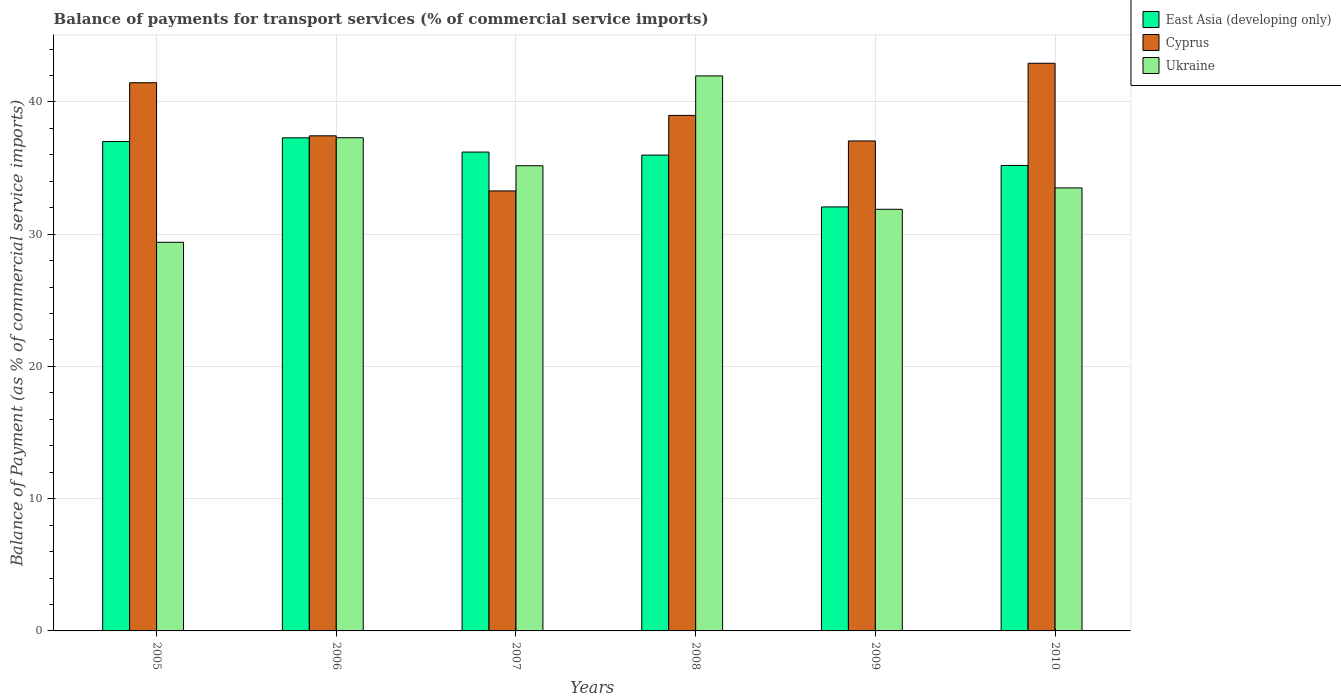Are the number of bars per tick equal to the number of legend labels?
Give a very brief answer. Yes. How many bars are there on the 3rd tick from the right?
Offer a very short reply. 3. In how many cases, is the number of bars for a given year not equal to the number of legend labels?
Provide a short and direct response. 0. What is the balance of payments for transport services in Cyprus in 2007?
Your response must be concise. 33.27. Across all years, what is the maximum balance of payments for transport services in Ukraine?
Ensure brevity in your answer.  41.97. Across all years, what is the minimum balance of payments for transport services in Ukraine?
Ensure brevity in your answer.  29.39. In which year was the balance of payments for transport services in Ukraine minimum?
Keep it short and to the point. 2005. What is the total balance of payments for transport services in Cyprus in the graph?
Provide a succinct answer. 231.12. What is the difference between the balance of payments for transport services in Cyprus in 2005 and that in 2006?
Your answer should be compact. 4.01. What is the difference between the balance of payments for transport services in East Asia (developing only) in 2010 and the balance of payments for transport services in Ukraine in 2005?
Offer a terse response. 5.81. What is the average balance of payments for transport services in Cyprus per year?
Offer a very short reply. 38.52. In the year 2010, what is the difference between the balance of payments for transport services in East Asia (developing only) and balance of payments for transport services in Ukraine?
Provide a succinct answer. 1.7. What is the ratio of the balance of payments for transport services in Ukraine in 2006 to that in 2009?
Provide a succinct answer. 1.17. What is the difference between the highest and the second highest balance of payments for transport services in East Asia (developing only)?
Your answer should be very brief. 0.28. What is the difference between the highest and the lowest balance of payments for transport services in Ukraine?
Your answer should be compact. 12.58. Is the sum of the balance of payments for transport services in East Asia (developing only) in 2008 and 2010 greater than the maximum balance of payments for transport services in Cyprus across all years?
Ensure brevity in your answer.  Yes. What does the 2nd bar from the left in 2006 represents?
Keep it short and to the point. Cyprus. What does the 1st bar from the right in 2005 represents?
Your answer should be compact. Ukraine. How many bars are there?
Offer a terse response. 18. How many years are there in the graph?
Your answer should be compact. 6. What is the difference between two consecutive major ticks on the Y-axis?
Ensure brevity in your answer.  10. How many legend labels are there?
Your response must be concise. 3. What is the title of the graph?
Offer a terse response. Balance of payments for transport services (% of commercial service imports). What is the label or title of the X-axis?
Your response must be concise. Years. What is the label or title of the Y-axis?
Your answer should be compact. Balance of Payment (as % of commercial service imports). What is the Balance of Payment (as % of commercial service imports) in East Asia (developing only) in 2005?
Your answer should be very brief. 37.01. What is the Balance of Payment (as % of commercial service imports) of Cyprus in 2005?
Offer a terse response. 41.45. What is the Balance of Payment (as % of commercial service imports) in Ukraine in 2005?
Your response must be concise. 29.39. What is the Balance of Payment (as % of commercial service imports) in East Asia (developing only) in 2006?
Offer a very short reply. 37.29. What is the Balance of Payment (as % of commercial service imports) of Cyprus in 2006?
Offer a very short reply. 37.44. What is the Balance of Payment (as % of commercial service imports) in Ukraine in 2006?
Give a very brief answer. 37.3. What is the Balance of Payment (as % of commercial service imports) in East Asia (developing only) in 2007?
Your response must be concise. 36.21. What is the Balance of Payment (as % of commercial service imports) of Cyprus in 2007?
Your response must be concise. 33.27. What is the Balance of Payment (as % of commercial service imports) of Ukraine in 2007?
Offer a very short reply. 35.18. What is the Balance of Payment (as % of commercial service imports) of East Asia (developing only) in 2008?
Make the answer very short. 35.98. What is the Balance of Payment (as % of commercial service imports) in Cyprus in 2008?
Provide a succinct answer. 38.98. What is the Balance of Payment (as % of commercial service imports) in Ukraine in 2008?
Offer a terse response. 41.97. What is the Balance of Payment (as % of commercial service imports) of East Asia (developing only) in 2009?
Provide a succinct answer. 32.06. What is the Balance of Payment (as % of commercial service imports) in Cyprus in 2009?
Offer a terse response. 37.05. What is the Balance of Payment (as % of commercial service imports) in Ukraine in 2009?
Your answer should be compact. 31.88. What is the Balance of Payment (as % of commercial service imports) of East Asia (developing only) in 2010?
Provide a short and direct response. 35.2. What is the Balance of Payment (as % of commercial service imports) in Cyprus in 2010?
Ensure brevity in your answer.  42.93. What is the Balance of Payment (as % of commercial service imports) in Ukraine in 2010?
Provide a short and direct response. 33.5. Across all years, what is the maximum Balance of Payment (as % of commercial service imports) of East Asia (developing only)?
Your answer should be compact. 37.29. Across all years, what is the maximum Balance of Payment (as % of commercial service imports) of Cyprus?
Give a very brief answer. 42.93. Across all years, what is the maximum Balance of Payment (as % of commercial service imports) in Ukraine?
Offer a terse response. 41.97. Across all years, what is the minimum Balance of Payment (as % of commercial service imports) of East Asia (developing only)?
Provide a succinct answer. 32.06. Across all years, what is the minimum Balance of Payment (as % of commercial service imports) in Cyprus?
Provide a short and direct response. 33.27. Across all years, what is the minimum Balance of Payment (as % of commercial service imports) in Ukraine?
Ensure brevity in your answer.  29.39. What is the total Balance of Payment (as % of commercial service imports) in East Asia (developing only) in the graph?
Provide a short and direct response. 213.74. What is the total Balance of Payment (as % of commercial service imports) in Cyprus in the graph?
Your response must be concise. 231.12. What is the total Balance of Payment (as % of commercial service imports) of Ukraine in the graph?
Provide a short and direct response. 209.21. What is the difference between the Balance of Payment (as % of commercial service imports) in East Asia (developing only) in 2005 and that in 2006?
Your answer should be compact. -0.28. What is the difference between the Balance of Payment (as % of commercial service imports) of Cyprus in 2005 and that in 2006?
Provide a succinct answer. 4.01. What is the difference between the Balance of Payment (as % of commercial service imports) of Ukraine in 2005 and that in 2006?
Make the answer very short. -7.91. What is the difference between the Balance of Payment (as % of commercial service imports) in East Asia (developing only) in 2005 and that in 2007?
Offer a very short reply. 0.8. What is the difference between the Balance of Payment (as % of commercial service imports) of Cyprus in 2005 and that in 2007?
Your answer should be compact. 8.18. What is the difference between the Balance of Payment (as % of commercial service imports) in Ukraine in 2005 and that in 2007?
Provide a short and direct response. -5.79. What is the difference between the Balance of Payment (as % of commercial service imports) of East Asia (developing only) in 2005 and that in 2008?
Your answer should be compact. 1.03. What is the difference between the Balance of Payment (as % of commercial service imports) in Cyprus in 2005 and that in 2008?
Keep it short and to the point. 2.47. What is the difference between the Balance of Payment (as % of commercial service imports) in Ukraine in 2005 and that in 2008?
Make the answer very short. -12.58. What is the difference between the Balance of Payment (as % of commercial service imports) of East Asia (developing only) in 2005 and that in 2009?
Your response must be concise. 4.94. What is the difference between the Balance of Payment (as % of commercial service imports) of Cyprus in 2005 and that in 2009?
Keep it short and to the point. 4.4. What is the difference between the Balance of Payment (as % of commercial service imports) in Ukraine in 2005 and that in 2009?
Offer a terse response. -2.49. What is the difference between the Balance of Payment (as % of commercial service imports) of East Asia (developing only) in 2005 and that in 2010?
Keep it short and to the point. 1.81. What is the difference between the Balance of Payment (as % of commercial service imports) in Cyprus in 2005 and that in 2010?
Ensure brevity in your answer.  -1.47. What is the difference between the Balance of Payment (as % of commercial service imports) in Ukraine in 2005 and that in 2010?
Offer a terse response. -4.11. What is the difference between the Balance of Payment (as % of commercial service imports) of East Asia (developing only) in 2006 and that in 2007?
Your answer should be very brief. 1.08. What is the difference between the Balance of Payment (as % of commercial service imports) in Cyprus in 2006 and that in 2007?
Ensure brevity in your answer.  4.17. What is the difference between the Balance of Payment (as % of commercial service imports) of Ukraine in 2006 and that in 2007?
Ensure brevity in your answer.  2.12. What is the difference between the Balance of Payment (as % of commercial service imports) of East Asia (developing only) in 2006 and that in 2008?
Make the answer very short. 1.31. What is the difference between the Balance of Payment (as % of commercial service imports) of Cyprus in 2006 and that in 2008?
Ensure brevity in your answer.  -1.54. What is the difference between the Balance of Payment (as % of commercial service imports) in Ukraine in 2006 and that in 2008?
Keep it short and to the point. -4.67. What is the difference between the Balance of Payment (as % of commercial service imports) of East Asia (developing only) in 2006 and that in 2009?
Your response must be concise. 5.22. What is the difference between the Balance of Payment (as % of commercial service imports) of Cyprus in 2006 and that in 2009?
Provide a short and direct response. 0.39. What is the difference between the Balance of Payment (as % of commercial service imports) of Ukraine in 2006 and that in 2009?
Your answer should be very brief. 5.41. What is the difference between the Balance of Payment (as % of commercial service imports) of East Asia (developing only) in 2006 and that in 2010?
Keep it short and to the point. 2.09. What is the difference between the Balance of Payment (as % of commercial service imports) in Cyprus in 2006 and that in 2010?
Your answer should be compact. -5.49. What is the difference between the Balance of Payment (as % of commercial service imports) in Ukraine in 2006 and that in 2010?
Offer a very short reply. 3.8. What is the difference between the Balance of Payment (as % of commercial service imports) in East Asia (developing only) in 2007 and that in 2008?
Your answer should be compact. 0.23. What is the difference between the Balance of Payment (as % of commercial service imports) in Cyprus in 2007 and that in 2008?
Offer a terse response. -5.71. What is the difference between the Balance of Payment (as % of commercial service imports) of Ukraine in 2007 and that in 2008?
Keep it short and to the point. -6.79. What is the difference between the Balance of Payment (as % of commercial service imports) of East Asia (developing only) in 2007 and that in 2009?
Offer a very short reply. 4.15. What is the difference between the Balance of Payment (as % of commercial service imports) of Cyprus in 2007 and that in 2009?
Provide a short and direct response. -3.78. What is the difference between the Balance of Payment (as % of commercial service imports) in Ukraine in 2007 and that in 2009?
Offer a very short reply. 3.29. What is the difference between the Balance of Payment (as % of commercial service imports) in East Asia (developing only) in 2007 and that in 2010?
Your response must be concise. 1.01. What is the difference between the Balance of Payment (as % of commercial service imports) in Cyprus in 2007 and that in 2010?
Your response must be concise. -9.65. What is the difference between the Balance of Payment (as % of commercial service imports) of Ukraine in 2007 and that in 2010?
Your response must be concise. 1.68. What is the difference between the Balance of Payment (as % of commercial service imports) in East Asia (developing only) in 2008 and that in 2009?
Offer a very short reply. 3.92. What is the difference between the Balance of Payment (as % of commercial service imports) in Cyprus in 2008 and that in 2009?
Your answer should be compact. 1.93. What is the difference between the Balance of Payment (as % of commercial service imports) in Ukraine in 2008 and that in 2009?
Provide a short and direct response. 10.09. What is the difference between the Balance of Payment (as % of commercial service imports) of East Asia (developing only) in 2008 and that in 2010?
Make the answer very short. 0.78. What is the difference between the Balance of Payment (as % of commercial service imports) in Cyprus in 2008 and that in 2010?
Your answer should be compact. -3.94. What is the difference between the Balance of Payment (as % of commercial service imports) of Ukraine in 2008 and that in 2010?
Your response must be concise. 8.47. What is the difference between the Balance of Payment (as % of commercial service imports) of East Asia (developing only) in 2009 and that in 2010?
Your answer should be very brief. -3.13. What is the difference between the Balance of Payment (as % of commercial service imports) of Cyprus in 2009 and that in 2010?
Provide a short and direct response. -5.87. What is the difference between the Balance of Payment (as % of commercial service imports) in Ukraine in 2009 and that in 2010?
Ensure brevity in your answer.  -1.61. What is the difference between the Balance of Payment (as % of commercial service imports) of East Asia (developing only) in 2005 and the Balance of Payment (as % of commercial service imports) of Cyprus in 2006?
Make the answer very short. -0.43. What is the difference between the Balance of Payment (as % of commercial service imports) of East Asia (developing only) in 2005 and the Balance of Payment (as % of commercial service imports) of Ukraine in 2006?
Give a very brief answer. -0.29. What is the difference between the Balance of Payment (as % of commercial service imports) in Cyprus in 2005 and the Balance of Payment (as % of commercial service imports) in Ukraine in 2006?
Offer a terse response. 4.16. What is the difference between the Balance of Payment (as % of commercial service imports) of East Asia (developing only) in 2005 and the Balance of Payment (as % of commercial service imports) of Cyprus in 2007?
Your answer should be compact. 3.73. What is the difference between the Balance of Payment (as % of commercial service imports) in East Asia (developing only) in 2005 and the Balance of Payment (as % of commercial service imports) in Ukraine in 2007?
Make the answer very short. 1.83. What is the difference between the Balance of Payment (as % of commercial service imports) in Cyprus in 2005 and the Balance of Payment (as % of commercial service imports) in Ukraine in 2007?
Your answer should be compact. 6.28. What is the difference between the Balance of Payment (as % of commercial service imports) of East Asia (developing only) in 2005 and the Balance of Payment (as % of commercial service imports) of Cyprus in 2008?
Provide a succinct answer. -1.98. What is the difference between the Balance of Payment (as % of commercial service imports) of East Asia (developing only) in 2005 and the Balance of Payment (as % of commercial service imports) of Ukraine in 2008?
Provide a succinct answer. -4.96. What is the difference between the Balance of Payment (as % of commercial service imports) of Cyprus in 2005 and the Balance of Payment (as % of commercial service imports) of Ukraine in 2008?
Offer a very short reply. -0.52. What is the difference between the Balance of Payment (as % of commercial service imports) in East Asia (developing only) in 2005 and the Balance of Payment (as % of commercial service imports) in Cyprus in 2009?
Give a very brief answer. -0.04. What is the difference between the Balance of Payment (as % of commercial service imports) of East Asia (developing only) in 2005 and the Balance of Payment (as % of commercial service imports) of Ukraine in 2009?
Make the answer very short. 5.12. What is the difference between the Balance of Payment (as % of commercial service imports) of Cyprus in 2005 and the Balance of Payment (as % of commercial service imports) of Ukraine in 2009?
Offer a very short reply. 9.57. What is the difference between the Balance of Payment (as % of commercial service imports) of East Asia (developing only) in 2005 and the Balance of Payment (as % of commercial service imports) of Cyprus in 2010?
Your answer should be compact. -5.92. What is the difference between the Balance of Payment (as % of commercial service imports) of East Asia (developing only) in 2005 and the Balance of Payment (as % of commercial service imports) of Ukraine in 2010?
Your answer should be compact. 3.51. What is the difference between the Balance of Payment (as % of commercial service imports) in Cyprus in 2005 and the Balance of Payment (as % of commercial service imports) in Ukraine in 2010?
Your response must be concise. 7.96. What is the difference between the Balance of Payment (as % of commercial service imports) of East Asia (developing only) in 2006 and the Balance of Payment (as % of commercial service imports) of Cyprus in 2007?
Offer a terse response. 4.01. What is the difference between the Balance of Payment (as % of commercial service imports) in East Asia (developing only) in 2006 and the Balance of Payment (as % of commercial service imports) in Ukraine in 2007?
Your answer should be very brief. 2.11. What is the difference between the Balance of Payment (as % of commercial service imports) in Cyprus in 2006 and the Balance of Payment (as % of commercial service imports) in Ukraine in 2007?
Ensure brevity in your answer.  2.26. What is the difference between the Balance of Payment (as % of commercial service imports) in East Asia (developing only) in 2006 and the Balance of Payment (as % of commercial service imports) in Cyprus in 2008?
Provide a short and direct response. -1.7. What is the difference between the Balance of Payment (as % of commercial service imports) in East Asia (developing only) in 2006 and the Balance of Payment (as % of commercial service imports) in Ukraine in 2008?
Offer a very short reply. -4.68. What is the difference between the Balance of Payment (as % of commercial service imports) in Cyprus in 2006 and the Balance of Payment (as % of commercial service imports) in Ukraine in 2008?
Provide a succinct answer. -4.53. What is the difference between the Balance of Payment (as % of commercial service imports) in East Asia (developing only) in 2006 and the Balance of Payment (as % of commercial service imports) in Cyprus in 2009?
Your answer should be compact. 0.24. What is the difference between the Balance of Payment (as % of commercial service imports) in East Asia (developing only) in 2006 and the Balance of Payment (as % of commercial service imports) in Ukraine in 2009?
Your answer should be very brief. 5.4. What is the difference between the Balance of Payment (as % of commercial service imports) in Cyprus in 2006 and the Balance of Payment (as % of commercial service imports) in Ukraine in 2009?
Keep it short and to the point. 5.56. What is the difference between the Balance of Payment (as % of commercial service imports) in East Asia (developing only) in 2006 and the Balance of Payment (as % of commercial service imports) in Cyprus in 2010?
Provide a succinct answer. -5.64. What is the difference between the Balance of Payment (as % of commercial service imports) of East Asia (developing only) in 2006 and the Balance of Payment (as % of commercial service imports) of Ukraine in 2010?
Give a very brief answer. 3.79. What is the difference between the Balance of Payment (as % of commercial service imports) of Cyprus in 2006 and the Balance of Payment (as % of commercial service imports) of Ukraine in 2010?
Your response must be concise. 3.94. What is the difference between the Balance of Payment (as % of commercial service imports) of East Asia (developing only) in 2007 and the Balance of Payment (as % of commercial service imports) of Cyprus in 2008?
Provide a short and direct response. -2.77. What is the difference between the Balance of Payment (as % of commercial service imports) in East Asia (developing only) in 2007 and the Balance of Payment (as % of commercial service imports) in Ukraine in 2008?
Give a very brief answer. -5.76. What is the difference between the Balance of Payment (as % of commercial service imports) in Cyprus in 2007 and the Balance of Payment (as % of commercial service imports) in Ukraine in 2008?
Provide a succinct answer. -8.7. What is the difference between the Balance of Payment (as % of commercial service imports) of East Asia (developing only) in 2007 and the Balance of Payment (as % of commercial service imports) of Cyprus in 2009?
Offer a very short reply. -0.84. What is the difference between the Balance of Payment (as % of commercial service imports) of East Asia (developing only) in 2007 and the Balance of Payment (as % of commercial service imports) of Ukraine in 2009?
Your answer should be compact. 4.33. What is the difference between the Balance of Payment (as % of commercial service imports) in Cyprus in 2007 and the Balance of Payment (as % of commercial service imports) in Ukraine in 2009?
Make the answer very short. 1.39. What is the difference between the Balance of Payment (as % of commercial service imports) of East Asia (developing only) in 2007 and the Balance of Payment (as % of commercial service imports) of Cyprus in 2010?
Keep it short and to the point. -6.72. What is the difference between the Balance of Payment (as % of commercial service imports) of East Asia (developing only) in 2007 and the Balance of Payment (as % of commercial service imports) of Ukraine in 2010?
Offer a very short reply. 2.71. What is the difference between the Balance of Payment (as % of commercial service imports) of Cyprus in 2007 and the Balance of Payment (as % of commercial service imports) of Ukraine in 2010?
Ensure brevity in your answer.  -0.23. What is the difference between the Balance of Payment (as % of commercial service imports) in East Asia (developing only) in 2008 and the Balance of Payment (as % of commercial service imports) in Cyprus in 2009?
Offer a very short reply. -1.07. What is the difference between the Balance of Payment (as % of commercial service imports) in East Asia (developing only) in 2008 and the Balance of Payment (as % of commercial service imports) in Ukraine in 2009?
Offer a very short reply. 4.1. What is the difference between the Balance of Payment (as % of commercial service imports) in Cyprus in 2008 and the Balance of Payment (as % of commercial service imports) in Ukraine in 2009?
Give a very brief answer. 7.1. What is the difference between the Balance of Payment (as % of commercial service imports) of East Asia (developing only) in 2008 and the Balance of Payment (as % of commercial service imports) of Cyprus in 2010?
Your answer should be compact. -6.95. What is the difference between the Balance of Payment (as % of commercial service imports) of East Asia (developing only) in 2008 and the Balance of Payment (as % of commercial service imports) of Ukraine in 2010?
Give a very brief answer. 2.48. What is the difference between the Balance of Payment (as % of commercial service imports) of Cyprus in 2008 and the Balance of Payment (as % of commercial service imports) of Ukraine in 2010?
Your answer should be compact. 5.48. What is the difference between the Balance of Payment (as % of commercial service imports) of East Asia (developing only) in 2009 and the Balance of Payment (as % of commercial service imports) of Cyprus in 2010?
Ensure brevity in your answer.  -10.86. What is the difference between the Balance of Payment (as % of commercial service imports) in East Asia (developing only) in 2009 and the Balance of Payment (as % of commercial service imports) in Ukraine in 2010?
Provide a succinct answer. -1.44. What is the difference between the Balance of Payment (as % of commercial service imports) in Cyprus in 2009 and the Balance of Payment (as % of commercial service imports) in Ukraine in 2010?
Make the answer very short. 3.55. What is the average Balance of Payment (as % of commercial service imports) of East Asia (developing only) per year?
Offer a terse response. 35.62. What is the average Balance of Payment (as % of commercial service imports) in Cyprus per year?
Make the answer very short. 38.52. What is the average Balance of Payment (as % of commercial service imports) of Ukraine per year?
Provide a short and direct response. 34.87. In the year 2005, what is the difference between the Balance of Payment (as % of commercial service imports) in East Asia (developing only) and Balance of Payment (as % of commercial service imports) in Cyprus?
Your answer should be very brief. -4.45. In the year 2005, what is the difference between the Balance of Payment (as % of commercial service imports) of East Asia (developing only) and Balance of Payment (as % of commercial service imports) of Ukraine?
Keep it short and to the point. 7.62. In the year 2005, what is the difference between the Balance of Payment (as % of commercial service imports) in Cyprus and Balance of Payment (as % of commercial service imports) in Ukraine?
Make the answer very short. 12.06. In the year 2006, what is the difference between the Balance of Payment (as % of commercial service imports) of East Asia (developing only) and Balance of Payment (as % of commercial service imports) of Cyprus?
Offer a terse response. -0.15. In the year 2006, what is the difference between the Balance of Payment (as % of commercial service imports) of East Asia (developing only) and Balance of Payment (as % of commercial service imports) of Ukraine?
Provide a short and direct response. -0.01. In the year 2006, what is the difference between the Balance of Payment (as % of commercial service imports) of Cyprus and Balance of Payment (as % of commercial service imports) of Ukraine?
Offer a very short reply. 0.14. In the year 2007, what is the difference between the Balance of Payment (as % of commercial service imports) of East Asia (developing only) and Balance of Payment (as % of commercial service imports) of Cyprus?
Give a very brief answer. 2.94. In the year 2007, what is the difference between the Balance of Payment (as % of commercial service imports) in East Asia (developing only) and Balance of Payment (as % of commercial service imports) in Ukraine?
Your answer should be compact. 1.03. In the year 2007, what is the difference between the Balance of Payment (as % of commercial service imports) of Cyprus and Balance of Payment (as % of commercial service imports) of Ukraine?
Give a very brief answer. -1.91. In the year 2008, what is the difference between the Balance of Payment (as % of commercial service imports) of East Asia (developing only) and Balance of Payment (as % of commercial service imports) of Cyprus?
Provide a short and direct response. -3. In the year 2008, what is the difference between the Balance of Payment (as % of commercial service imports) of East Asia (developing only) and Balance of Payment (as % of commercial service imports) of Ukraine?
Give a very brief answer. -5.99. In the year 2008, what is the difference between the Balance of Payment (as % of commercial service imports) in Cyprus and Balance of Payment (as % of commercial service imports) in Ukraine?
Provide a succinct answer. -2.99. In the year 2009, what is the difference between the Balance of Payment (as % of commercial service imports) of East Asia (developing only) and Balance of Payment (as % of commercial service imports) of Cyprus?
Ensure brevity in your answer.  -4.99. In the year 2009, what is the difference between the Balance of Payment (as % of commercial service imports) in East Asia (developing only) and Balance of Payment (as % of commercial service imports) in Ukraine?
Give a very brief answer. 0.18. In the year 2009, what is the difference between the Balance of Payment (as % of commercial service imports) of Cyprus and Balance of Payment (as % of commercial service imports) of Ukraine?
Make the answer very short. 5.17. In the year 2010, what is the difference between the Balance of Payment (as % of commercial service imports) of East Asia (developing only) and Balance of Payment (as % of commercial service imports) of Cyprus?
Offer a very short reply. -7.73. In the year 2010, what is the difference between the Balance of Payment (as % of commercial service imports) of East Asia (developing only) and Balance of Payment (as % of commercial service imports) of Ukraine?
Ensure brevity in your answer.  1.7. In the year 2010, what is the difference between the Balance of Payment (as % of commercial service imports) in Cyprus and Balance of Payment (as % of commercial service imports) in Ukraine?
Your answer should be very brief. 9.43. What is the ratio of the Balance of Payment (as % of commercial service imports) in East Asia (developing only) in 2005 to that in 2006?
Give a very brief answer. 0.99. What is the ratio of the Balance of Payment (as % of commercial service imports) in Cyprus in 2005 to that in 2006?
Make the answer very short. 1.11. What is the ratio of the Balance of Payment (as % of commercial service imports) of Ukraine in 2005 to that in 2006?
Ensure brevity in your answer.  0.79. What is the ratio of the Balance of Payment (as % of commercial service imports) in Cyprus in 2005 to that in 2007?
Provide a succinct answer. 1.25. What is the ratio of the Balance of Payment (as % of commercial service imports) in Ukraine in 2005 to that in 2007?
Provide a short and direct response. 0.84. What is the ratio of the Balance of Payment (as % of commercial service imports) in East Asia (developing only) in 2005 to that in 2008?
Provide a succinct answer. 1.03. What is the ratio of the Balance of Payment (as % of commercial service imports) of Cyprus in 2005 to that in 2008?
Your response must be concise. 1.06. What is the ratio of the Balance of Payment (as % of commercial service imports) in Ukraine in 2005 to that in 2008?
Make the answer very short. 0.7. What is the ratio of the Balance of Payment (as % of commercial service imports) of East Asia (developing only) in 2005 to that in 2009?
Your answer should be compact. 1.15. What is the ratio of the Balance of Payment (as % of commercial service imports) in Cyprus in 2005 to that in 2009?
Offer a very short reply. 1.12. What is the ratio of the Balance of Payment (as % of commercial service imports) in Ukraine in 2005 to that in 2009?
Offer a very short reply. 0.92. What is the ratio of the Balance of Payment (as % of commercial service imports) of East Asia (developing only) in 2005 to that in 2010?
Offer a very short reply. 1.05. What is the ratio of the Balance of Payment (as % of commercial service imports) in Cyprus in 2005 to that in 2010?
Provide a short and direct response. 0.97. What is the ratio of the Balance of Payment (as % of commercial service imports) of Ukraine in 2005 to that in 2010?
Make the answer very short. 0.88. What is the ratio of the Balance of Payment (as % of commercial service imports) of East Asia (developing only) in 2006 to that in 2007?
Offer a terse response. 1.03. What is the ratio of the Balance of Payment (as % of commercial service imports) in Cyprus in 2006 to that in 2007?
Make the answer very short. 1.13. What is the ratio of the Balance of Payment (as % of commercial service imports) of Ukraine in 2006 to that in 2007?
Offer a very short reply. 1.06. What is the ratio of the Balance of Payment (as % of commercial service imports) of East Asia (developing only) in 2006 to that in 2008?
Ensure brevity in your answer.  1.04. What is the ratio of the Balance of Payment (as % of commercial service imports) of Cyprus in 2006 to that in 2008?
Ensure brevity in your answer.  0.96. What is the ratio of the Balance of Payment (as % of commercial service imports) of Ukraine in 2006 to that in 2008?
Provide a short and direct response. 0.89. What is the ratio of the Balance of Payment (as % of commercial service imports) of East Asia (developing only) in 2006 to that in 2009?
Make the answer very short. 1.16. What is the ratio of the Balance of Payment (as % of commercial service imports) in Cyprus in 2006 to that in 2009?
Give a very brief answer. 1.01. What is the ratio of the Balance of Payment (as % of commercial service imports) of Ukraine in 2006 to that in 2009?
Make the answer very short. 1.17. What is the ratio of the Balance of Payment (as % of commercial service imports) of East Asia (developing only) in 2006 to that in 2010?
Keep it short and to the point. 1.06. What is the ratio of the Balance of Payment (as % of commercial service imports) in Cyprus in 2006 to that in 2010?
Your response must be concise. 0.87. What is the ratio of the Balance of Payment (as % of commercial service imports) in Ukraine in 2006 to that in 2010?
Your answer should be compact. 1.11. What is the ratio of the Balance of Payment (as % of commercial service imports) in East Asia (developing only) in 2007 to that in 2008?
Provide a short and direct response. 1.01. What is the ratio of the Balance of Payment (as % of commercial service imports) of Cyprus in 2007 to that in 2008?
Your answer should be compact. 0.85. What is the ratio of the Balance of Payment (as % of commercial service imports) of Ukraine in 2007 to that in 2008?
Provide a succinct answer. 0.84. What is the ratio of the Balance of Payment (as % of commercial service imports) of East Asia (developing only) in 2007 to that in 2009?
Your answer should be compact. 1.13. What is the ratio of the Balance of Payment (as % of commercial service imports) of Cyprus in 2007 to that in 2009?
Offer a terse response. 0.9. What is the ratio of the Balance of Payment (as % of commercial service imports) of Ukraine in 2007 to that in 2009?
Your answer should be very brief. 1.1. What is the ratio of the Balance of Payment (as % of commercial service imports) of East Asia (developing only) in 2007 to that in 2010?
Your response must be concise. 1.03. What is the ratio of the Balance of Payment (as % of commercial service imports) of Cyprus in 2007 to that in 2010?
Offer a very short reply. 0.78. What is the ratio of the Balance of Payment (as % of commercial service imports) of Ukraine in 2007 to that in 2010?
Your response must be concise. 1.05. What is the ratio of the Balance of Payment (as % of commercial service imports) of East Asia (developing only) in 2008 to that in 2009?
Your response must be concise. 1.12. What is the ratio of the Balance of Payment (as % of commercial service imports) of Cyprus in 2008 to that in 2009?
Ensure brevity in your answer.  1.05. What is the ratio of the Balance of Payment (as % of commercial service imports) of Ukraine in 2008 to that in 2009?
Provide a short and direct response. 1.32. What is the ratio of the Balance of Payment (as % of commercial service imports) in East Asia (developing only) in 2008 to that in 2010?
Make the answer very short. 1.02. What is the ratio of the Balance of Payment (as % of commercial service imports) in Cyprus in 2008 to that in 2010?
Keep it short and to the point. 0.91. What is the ratio of the Balance of Payment (as % of commercial service imports) in Ukraine in 2008 to that in 2010?
Your answer should be compact. 1.25. What is the ratio of the Balance of Payment (as % of commercial service imports) in East Asia (developing only) in 2009 to that in 2010?
Offer a terse response. 0.91. What is the ratio of the Balance of Payment (as % of commercial service imports) of Cyprus in 2009 to that in 2010?
Your answer should be very brief. 0.86. What is the ratio of the Balance of Payment (as % of commercial service imports) of Ukraine in 2009 to that in 2010?
Offer a terse response. 0.95. What is the difference between the highest and the second highest Balance of Payment (as % of commercial service imports) in East Asia (developing only)?
Make the answer very short. 0.28. What is the difference between the highest and the second highest Balance of Payment (as % of commercial service imports) of Cyprus?
Keep it short and to the point. 1.47. What is the difference between the highest and the second highest Balance of Payment (as % of commercial service imports) of Ukraine?
Offer a terse response. 4.67. What is the difference between the highest and the lowest Balance of Payment (as % of commercial service imports) in East Asia (developing only)?
Give a very brief answer. 5.22. What is the difference between the highest and the lowest Balance of Payment (as % of commercial service imports) of Cyprus?
Your response must be concise. 9.65. What is the difference between the highest and the lowest Balance of Payment (as % of commercial service imports) of Ukraine?
Provide a succinct answer. 12.58. 